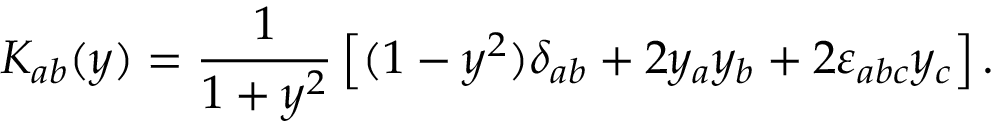Convert formula to latex. <formula><loc_0><loc_0><loc_500><loc_500>K _ { a b } ( y ) = \frac { 1 } 1 + y ^ { 2 } } \left [ ( 1 - y ^ { 2 } ) \delta _ { a b } + 2 y _ { a } y _ { b } + 2 \varepsilon _ { a b c } y _ { c } \right ] .</formula> 